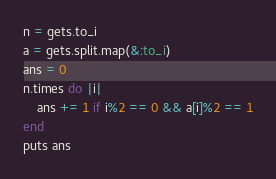Convert code to text. <code><loc_0><loc_0><loc_500><loc_500><_Ruby_>n = gets.to_i
a = gets.split.map(&:to_i)
ans = 0
n.times do |i|
    ans += 1 if i%2 == 0 && a[i]%2 == 1
end
puts ans</code> 